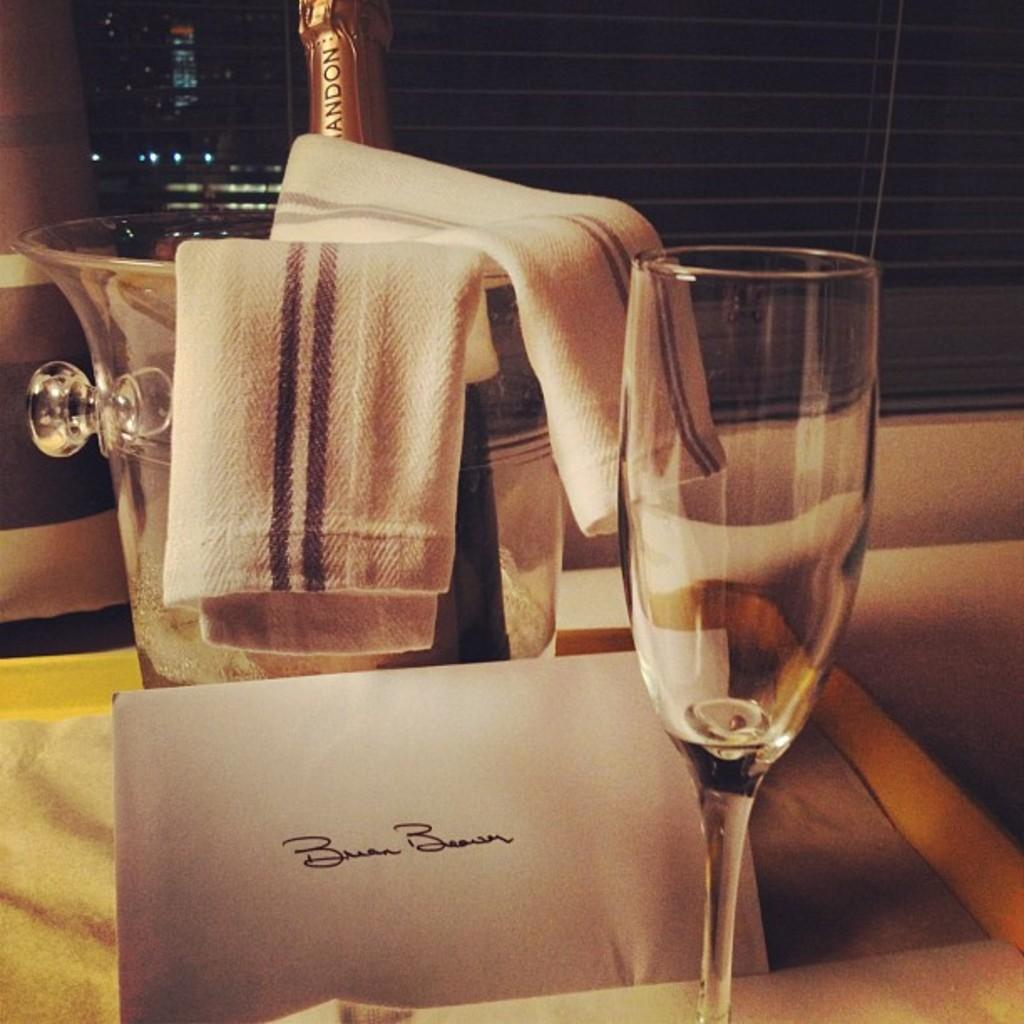What type of glass is present in the image? There is a wine glass in the image. What is the wine glass holding? The wine glass is holding wine, as there is a wine bottle in the image. Where are the wine glass and wine bottle located? They are in a glass bucket. What is covering the glass bucket? There is a cloth above the glass bucket. What is placed in front of the glass bucket? There is a card in front of the glass bucket. On what surface are the objects placed? The objects are on a table. What can be seen in the background of the image? There is a wall visible in the background of the image. How many brothers are depicted in the image? There are no brothers present in the image. What type of trains can be seen passing by in the image? There are no trains present in the image. 